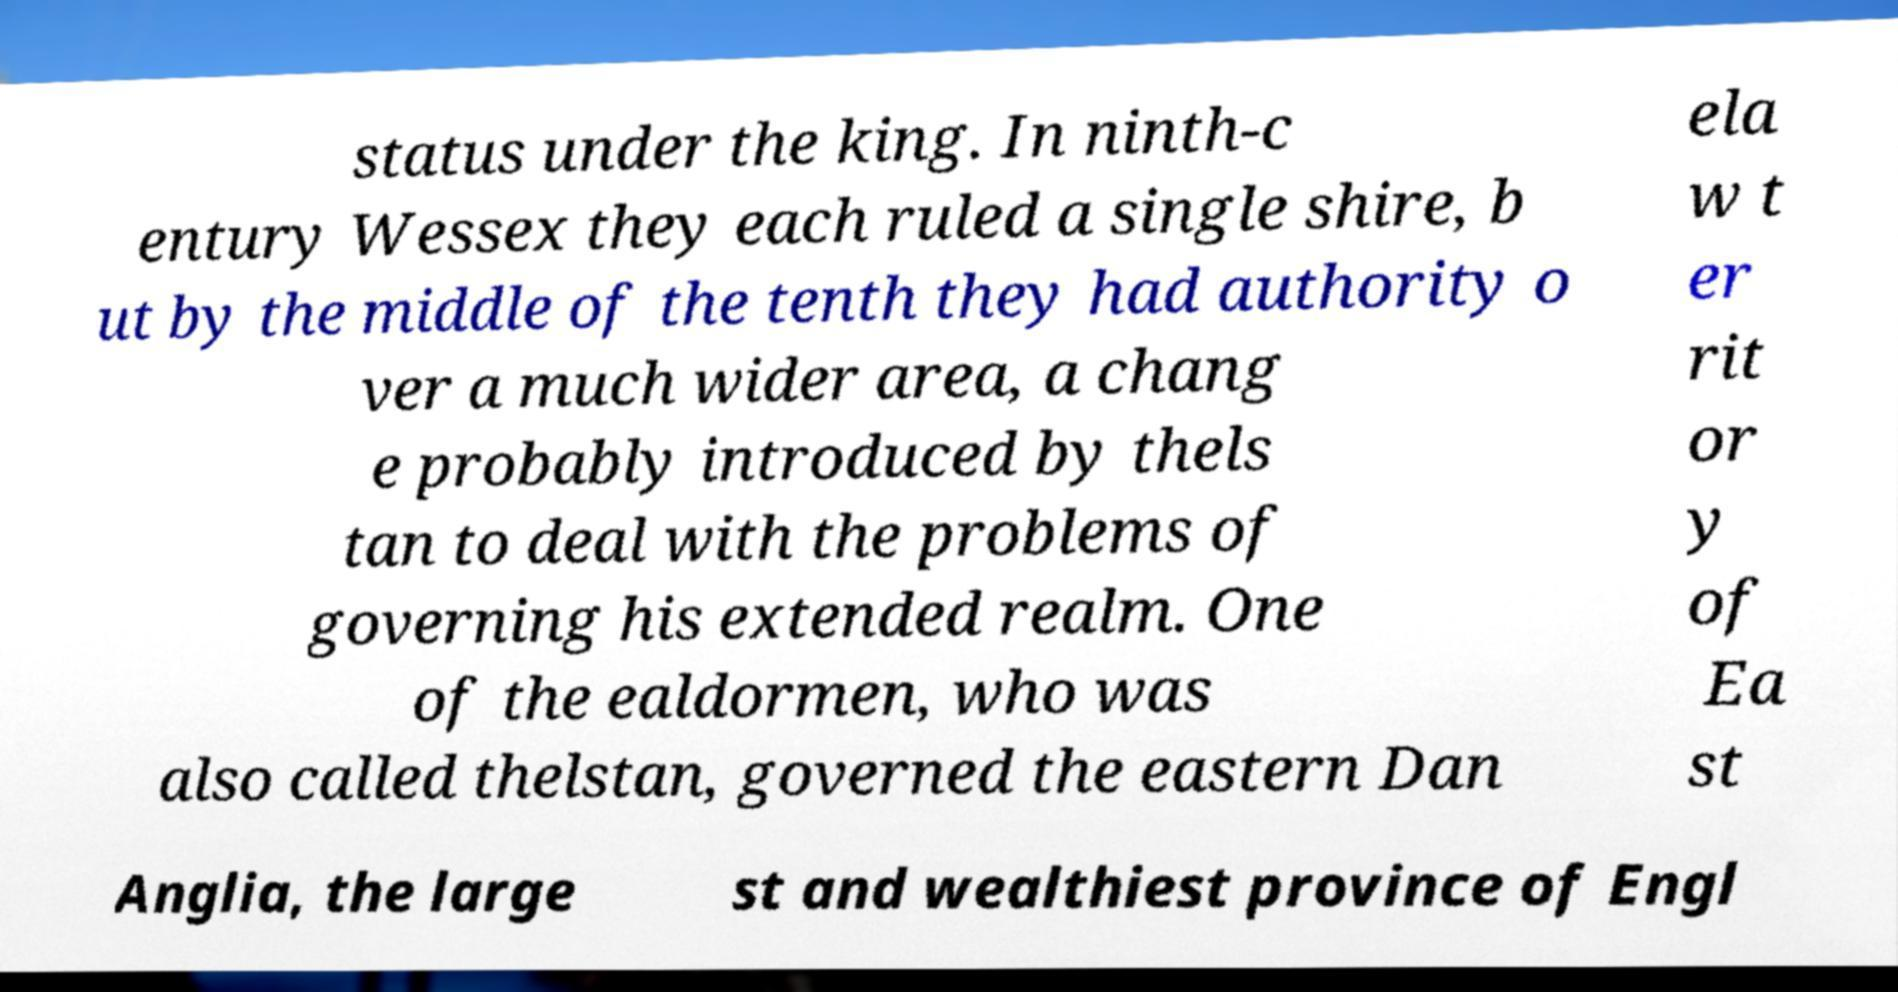Can you read and provide the text displayed in the image?This photo seems to have some interesting text. Can you extract and type it out for me? status under the king. In ninth-c entury Wessex they each ruled a single shire, b ut by the middle of the tenth they had authority o ver a much wider area, a chang e probably introduced by thels tan to deal with the problems of governing his extended realm. One of the ealdormen, who was also called thelstan, governed the eastern Dan ela w t er rit or y of Ea st Anglia, the large st and wealthiest province of Engl 